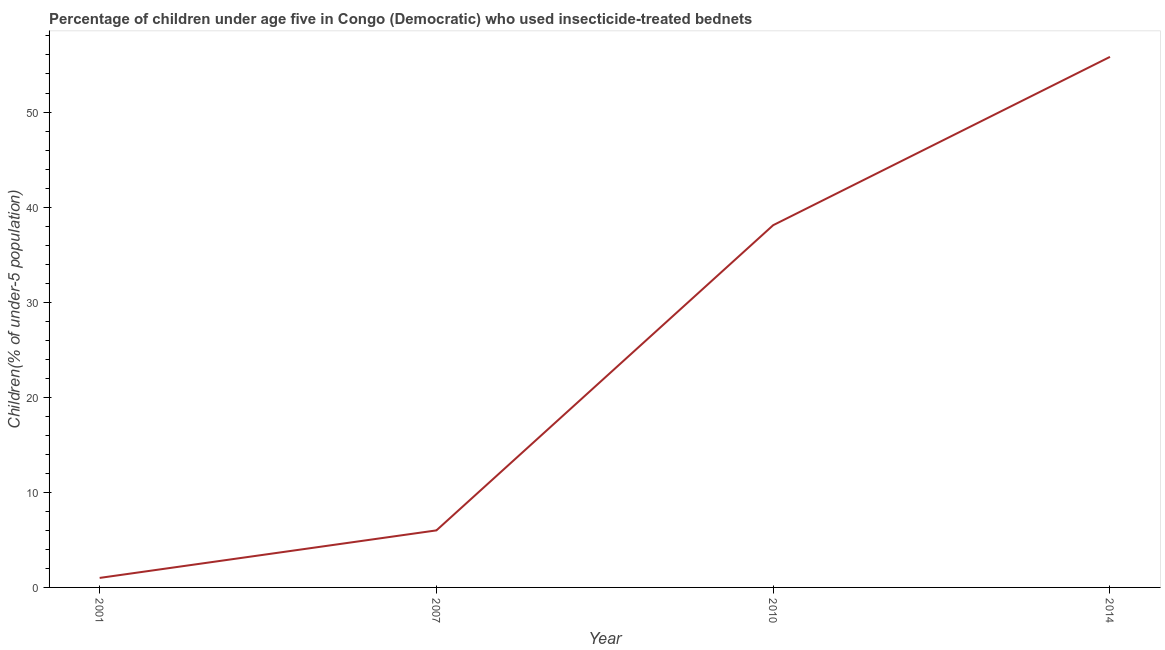What is the percentage of children who use of insecticide-treated bed nets in 2007?
Offer a terse response. 6. Across all years, what is the maximum percentage of children who use of insecticide-treated bed nets?
Make the answer very short. 55.8. In which year was the percentage of children who use of insecticide-treated bed nets minimum?
Make the answer very short. 2001. What is the sum of the percentage of children who use of insecticide-treated bed nets?
Give a very brief answer. 100.9. What is the average percentage of children who use of insecticide-treated bed nets per year?
Your answer should be compact. 25.23. What is the median percentage of children who use of insecticide-treated bed nets?
Give a very brief answer. 22.05. In how many years, is the percentage of children who use of insecticide-treated bed nets greater than 36 %?
Offer a very short reply. 2. Do a majority of the years between 2001 and 2014 (inclusive) have percentage of children who use of insecticide-treated bed nets greater than 46 %?
Offer a terse response. No. What is the ratio of the percentage of children who use of insecticide-treated bed nets in 2007 to that in 2010?
Give a very brief answer. 0.16. What is the difference between the highest and the second highest percentage of children who use of insecticide-treated bed nets?
Your answer should be very brief. 17.7. What is the difference between the highest and the lowest percentage of children who use of insecticide-treated bed nets?
Make the answer very short. 54.8. Does the percentage of children who use of insecticide-treated bed nets monotonically increase over the years?
Offer a terse response. Yes. How many lines are there?
Your answer should be very brief. 1. What is the difference between two consecutive major ticks on the Y-axis?
Your response must be concise. 10. Does the graph contain grids?
Your response must be concise. No. What is the title of the graph?
Make the answer very short. Percentage of children under age five in Congo (Democratic) who used insecticide-treated bednets. What is the label or title of the Y-axis?
Keep it short and to the point. Children(% of under-5 population). What is the Children(% of under-5 population) in 2007?
Keep it short and to the point. 6. What is the Children(% of under-5 population) of 2010?
Offer a terse response. 38.1. What is the Children(% of under-5 population) of 2014?
Your response must be concise. 55.8. What is the difference between the Children(% of under-5 population) in 2001 and 2007?
Give a very brief answer. -5. What is the difference between the Children(% of under-5 population) in 2001 and 2010?
Provide a short and direct response. -37.1. What is the difference between the Children(% of under-5 population) in 2001 and 2014?
Ensure brevity in your answer.  -54.8. What is the difference between the Children(% of under-5 population) in 2007 and 2010?
Ensure brevity in your answer.  -32.1. What is the difference between the Children(% of under-5 population) in 2007 and 2014?
Keep it short and to the point. -49.8. What is the difference between the Children(% of under-5 population) in 2010 and 2014?
Your answer should be compact. -17.7. What is the ratio of the Children(% of under-5 population) in 2001 to that in 2007?
Keep it short and to the point. 0.17. What is the ratio of the Children(% of under-5 population) in 2001 to that in 2010?
Give a very brief answer. 0.03. What is the ratio of the Children(% of under-5 population) in 2001 to that in 2014?
Keep it short and to the point. 0.02. What is the ratio of the Children(% of under-5 population) in 2007 to that in 2010?
Your answer should be compact. 0.16. What is the ratio of the Children(% of under-5 population) in 2007 to that in 2014?
Your answer should be very brief. 0.11. What is the ratio of the Children(% of under-5 population) in 2010 to that in 2014?
Offer a very short reply. 0.68. 